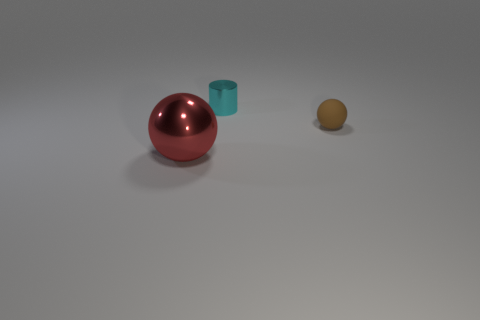Subtract all red balls. How many balls are left? 1 Add 1 red spheres. How many objects exist? 4 Subtract all spheres. How many objects are left? 1 Subtract 1 red spheres. How many objects are left? 2 Subtract all red cylinders. Subtract all blue cubes. How many cylinders are left? 1 Subtract all yellow cylinders. Subtract all tiny brown things. How many objects are left? 2 Add 3 red shiny balls. How many red shiny balls are left? 4 Add 2 tiny brown balls. How many tiny brown balls exist? 3 